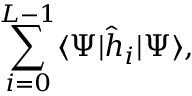Convert formula to latex. <formula><loc_0><loc_0><loc_500><loc_500>\sum _ { i = 0 } ^ { L - 1 } \langle \Psi | \hat { h } _ { i } | \Psi \rangle ,</formula> 